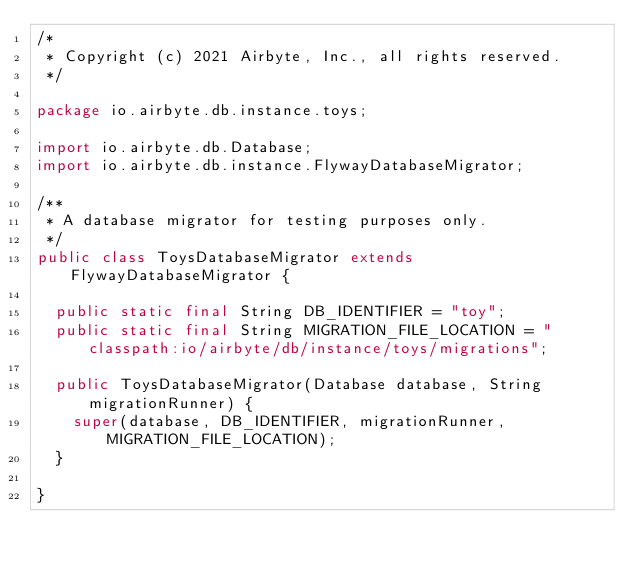Convert code to text. <code><loc_0><loc_0><loc_500><loc_500><_Java_>/*
 * Copyright (c) 2021 Airbyte, Inc., all rights reserved.
 */

package io.airbyte.db.instance.toys;

import io.airbyte.db.Database;
import io.airbyte.db.instance.FlywayDatabaseMigrator;

/**
 * A database migrator for testing purposes only.
 */
public class ToysDatabaseMigrator extends FlywayDatabaseMigrator {

  public static final String DB_IDENTIFIER = "toy";
  public static final String MIGRATION_FILE_LOCATION = "classpath:io/airbyte/db/instance/toys/migrations";

  public ToysDatabaseMigrator(Database database, String migrationRunner) {
    super(database, DB_IDENTIFIER, migrationRunner, MIGRATION_FILE_LOCATION);
  }

}
</code> 